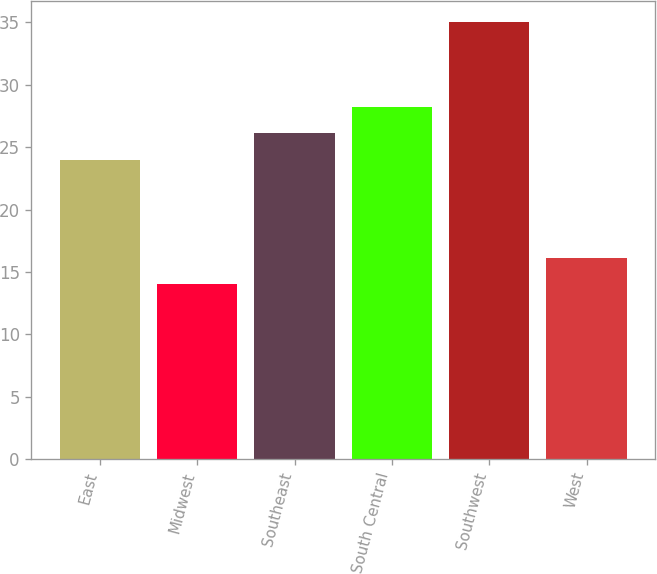Convert chart to OTSL. <chart><loc_0><loc_0><loc_500><loc_500><bar_chart><fcel>East<fcel>Midwest<fcel>Southeast<fcel>South Central<fcel>Southwest<fcel>West<nl><fcel>24<fcel>14<fcel>26.1<fcel>28.2<fcel>35<fcel>16.1<nl></chart> 